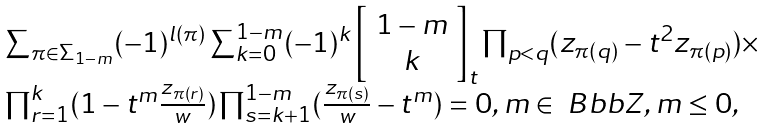Convert formula to latex. <formula><loc_0><loc_0><loc_500><loc_500>\begin{array} { l } \sum _ { \pi \in \Sigma _ { 1 - m } } ( - 1 ) ^ { l ( \pi ) } \sum _ { k = 0 } ^ { 1 - m } ( - 1 ) ^ { k } \left [ \begin{array} { c } 1 - m \\ k \end{array} \right ] _ { t } \prod _ { p < q } ( { z _ { \pi ( q ) } } - t ^ { 2 } { z _ { \pi ( p ) } } ) \times \\ \prod _ { r = 1 } ^ { k } ( 1 - t ^ { m } \frac { z _ { \pi ( r ) } } { w } ) \prod _ { s = k + 1 } ^ { 1 - m } ( \frac { z _ { \pi ( s ) } } { w } - t ^ { m } ) = 0 , m \in { \ B b b Z } , m \leq 0 , \end{array}</formula> 